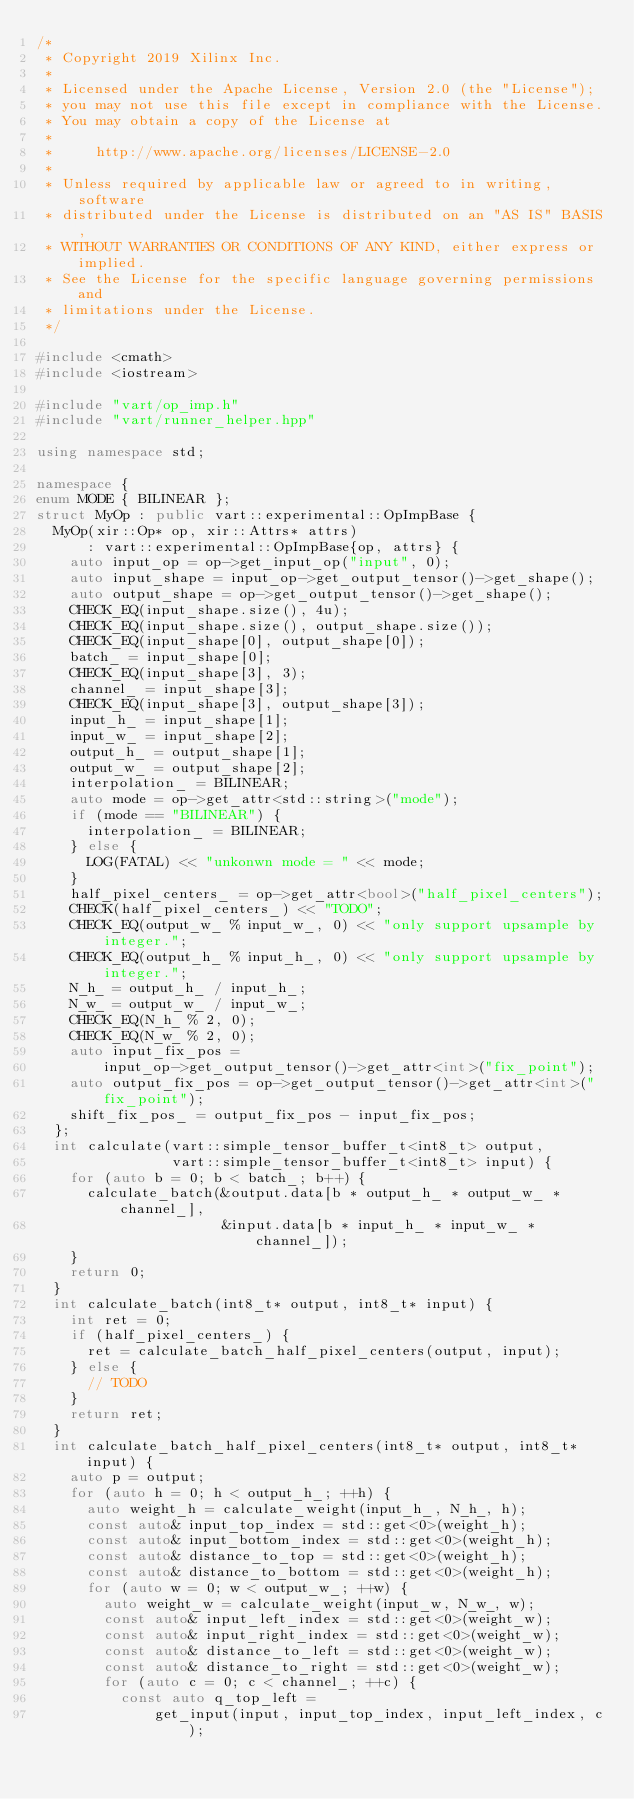<code> <loc_0><loc_0><loc_500><loc_500><_C++_>/*
 * Copyright 2019 Xilinx Inc.
 *
 * Licensed under the Apache License, Version 2.0 (the "License");
 * you may not use this file except in compliance with the License.
 * You may obtain a copy of the License at
 *
 *     http://www.apache.org/licenses/LICENSE-2.0
 *
 * Unless required by applicable law or agreed to in writing, software
 * distributed under the License is distributed on an "AS IS" BASIS,
 * WITHOUT WARRANTIES OR CONDITIONS OF ANY KIND, either express or implied.
 * See the License for the specific language governing permissions and
 * limitations under the License.
 */

#include <cmath>
#include <iostream>

#include "vart/op_imp.h"
#include "vart/runner_helper.hpp"

using namespace std;

namespace {
enum MODE { BILINEAR };
struct MyOp : public vart::experimental::OpImpBase {
  MyOp(xir::Op* op, xir::Attrs* attrs)
      : vart::experimental::OpImpBase{op, attrs} {
    auto input_op = op->get_input_op("input", 0);
    auto input_shape = input_op->get_output_tensor()->get_shape();
    auto output_shape = op->get_output_tensor()->get_shape();
    CHECK_EQ(input_shape.size(), 4u);
    CHECK_EQ(input_shape.size(), output_shape.size());
    CHECK_EQ(input_shape[0], output_shape[0]);
    batch_ = input_shape[0];
    CHECK_EQ(input_shape[3], 3);
    channel_ = input_shape[3];
    CHECK_EQ(input_shape[3], output_shape[3]);
    input_h_ = input_shape[1];
    input_w_ = input_shape[2];
    output_h_ = output_shape[1];
    output_w_ = output_shape[2];
    interpolation_ = BILINEAR;
    auto mode = op->get_attr<std::string>("mode");
    if (mode == "BILINEAR") {
      interpolation_ = BILINEAR;
    } else {
      LOG(FATAL) << "unkonwn mode = " << mode;
    }
    half_pixel_centers_ = op->get_attr<bool>("half_pixel_centers");
    CHECK(half_pixel_centers_) << "TODO";
    CHECK_EQ(output_w_ % input_w_, 0) << "only support upsample by integer.";
    CHECK_EQ(output_h_ % input_h_, 0) << "only support upsample by integer.";
    N_h_ = output_h_ / input_h_;
    N_w_ = output_w_ / input_w_;
    CHECK_EQ(N_h_ % 2, 0);
    CHECK_EQ(N_w_ % 2, 0);
    auto input_fix_pos =
        input_op->get_output_tensor()->get_attr<int>("fix_point");
    auto output_fix_pos = op->get_output_tensor()->get_attr<int>("fix_point");
    shift_fix_pos_ = output_fix_pos - input_fix_pos;
  };
  int calculate(vart::simple_tensor_buffer_t<int8_t> output,
                vart::simple_tensor_buffer_t<int8_t> input) {
    for (auto b = 0; b < batch_; b++) {
      calculate_batch(&output.data[b * output_h_ * output_w_ * channel_],
                      &input.data[b * input_h_ * input_w_ * channel_]);
    }
    return 0;
  }
  int calculate_batch(int8_t* output, int8_t* input) {
    int ret = 0;
    if (half_pixel_centers_) {
      ret = calculate_batch_half_pixel_centers(output, input);
    } else {
      // TODO
    }
    return ret;
  }
  int calculate_batch_half_pixel_centers(int8_t* output, int8_t* input) {
    auto p = output;
    for (auto h = 0; h < output_h_; ++h) {
      auto weight_h = calculate_weight(input_h_, N_h_, h);
      const auto& input_top_index = std::get<0>(weight_h);
      const auto& input_bottom_index = std::get<0>(weight_h);
      const auto& distance_to_top = std::get<0>(weight_h);
      const auto& distance_to_bottom = std::get<0>(weight_h);
      for (auto w = 0; w < output_w_; ++w) {
        auto weight_w = calculate_weight(input_w, N_w_, w);
        const auto& input_left_index = std::get<0>(weight_w);
        const auto& input_right_index = std::get<0>(weight_w);
        const auto& distance_to_left = std::get<0>(weight_w);
        const auto& distance_to_right = std::get<0>(weight_w);
        for (auto c = 0; c < channel_; ++c) {
          const auto q_top_left =
              get_input(input, input_top_index, input_left_index, c);</code> 